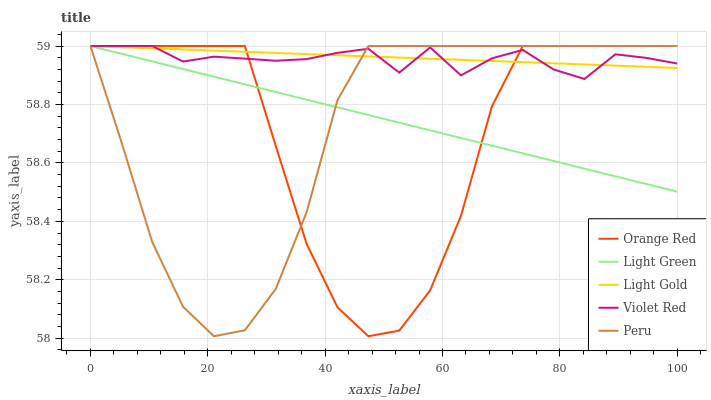Does Violet Red have the minimum area under the curve?
Answer yes or no. No. Does Violet Red have the maximum area under the curve?
Answer yes or no. No. Is Violet Red the smoothest?
Answer yes or no. No. Is Violet Red the roughest?
Answer yes or no. No. Does Violet Red have the lowest value?
Answer yes or no. No. 